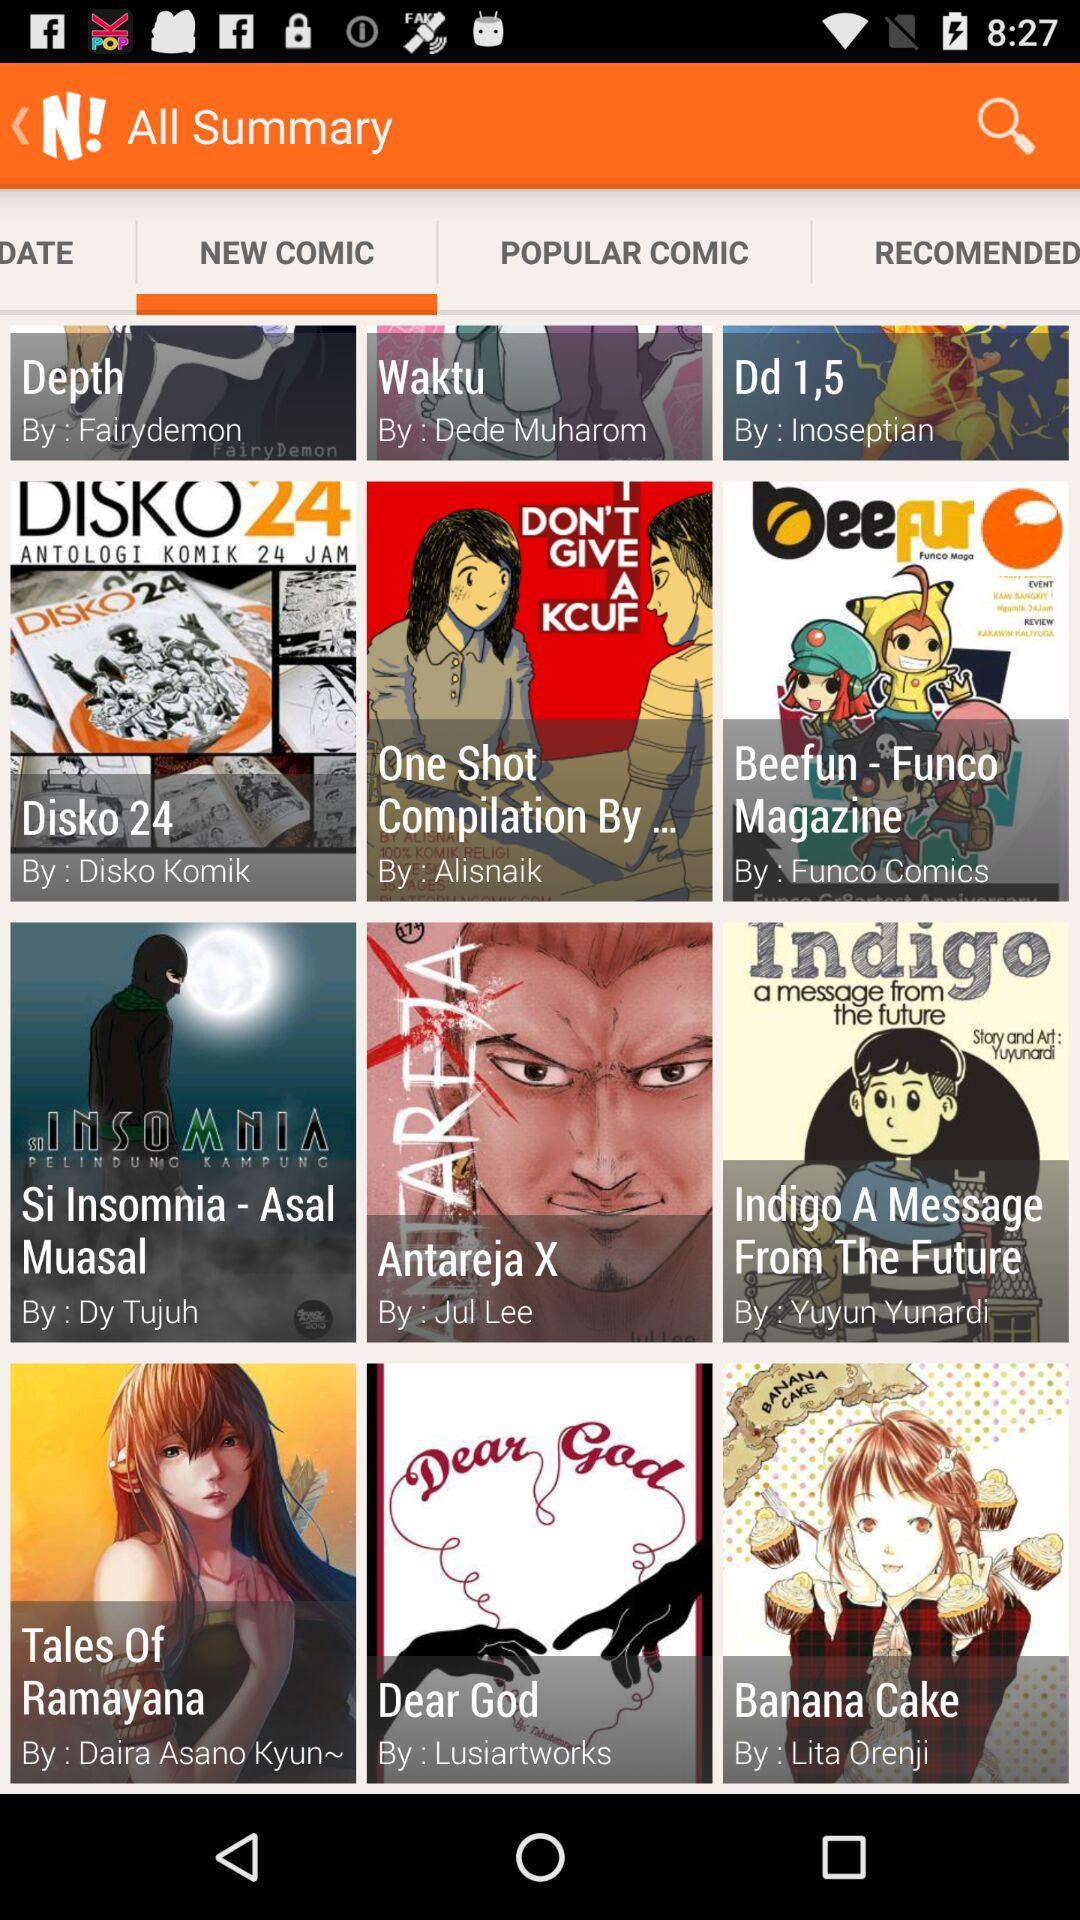Which comic is written by Dy Tujuh? The comic that is written by Dy Tujuh is "Si Insomnia - Asal Muasal". 